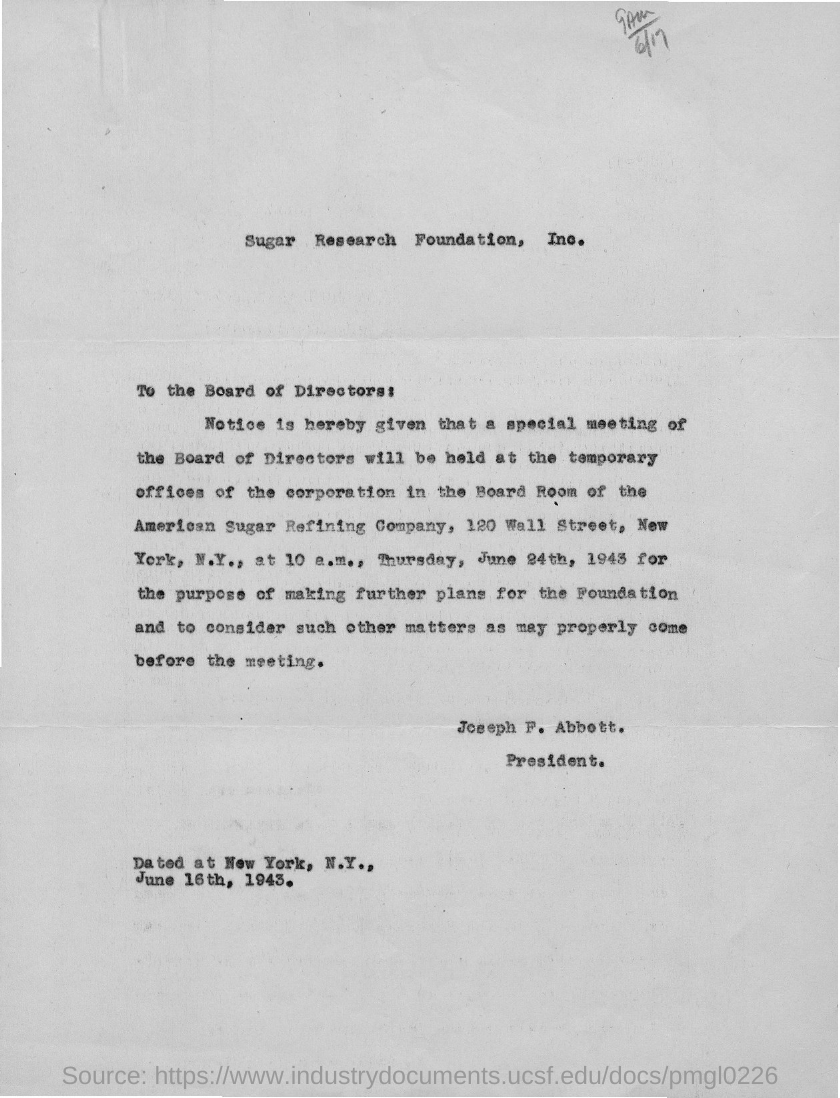What is the name of the ogranization in the title of the document?
Your answer should be very brief. Sugar Research Foundation, Inc. Who is the president?
Offer a terse response. Joseph F. Abbott. 